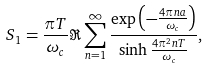<formula> <loc_0><loc_0><loc_500><loc_500>S _ { 1 } = \frac { \pi T } { \omega _ { c } } \Re \sum _ { n = 1 } ^ { \infty } \frac { \exp \left ( - \frac { 4 \pi n a } { \omega _ { c } } \right ) } { \sinh \frac { 4 \pi ^ { 2 } n T } { \omega _ { c } } } ,</formula> 